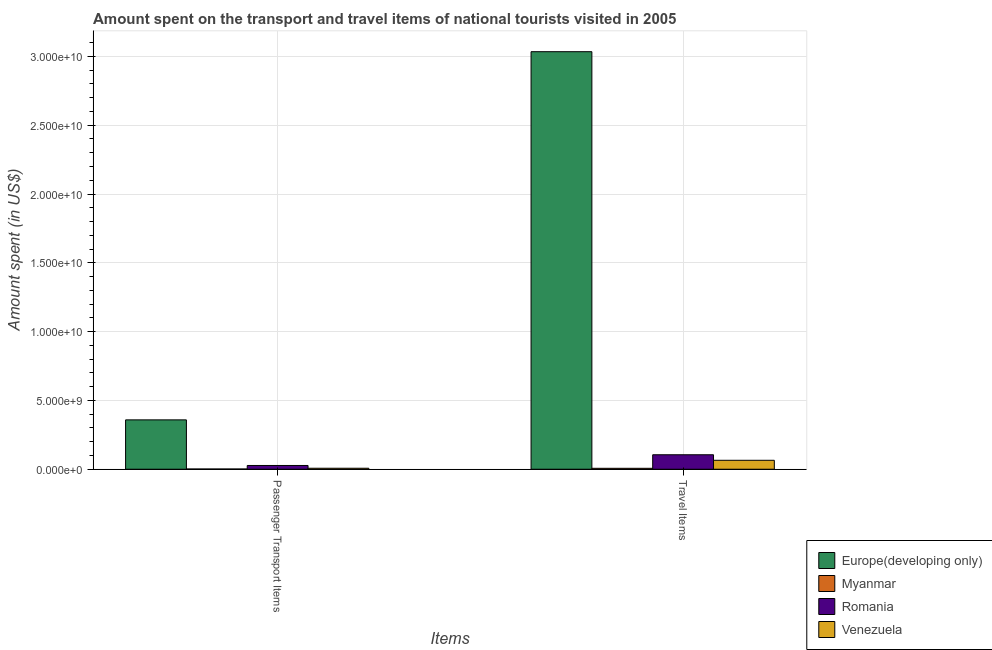How many bars are there on the 1st tick from the left?
Ensure brevity in your answer.  4. How many bars are there on the 1st tick from the right?
Your response must be concise. 4. What is the label of the 2nd group of bars from the left?
Make the answer very short. Travel Items. What is the amount spent in travel items in Romania?
Provide a short and direct response. 1.05e+09. Across all countries, what is the maximum amount spent in travel items?
Provide a short and direct response. 3.03e+1. Across all countries, what is the minimum amount spent on passenger transport items?
Provide a short and direct response. 1.60e+07. In which country was the amount spent in travel items maximum?
Provide a short and direct response. Europe(developing only). In which country was the amount spent in travel items minimum?
Your answer should be very brief. Myanmar. What is the total amount spent in travel items in the graph?
Give a very brief answer. 3.21e+1. What is the difference between the amount spent on passenger transport items in Venezuela and that in Myanmar?
Make the answer very short. 5.60e+07. What is the average amount spent on passenger transport items per country?
Your answer should be very brief. 9.87e+08. What is the difference between the amount spent on passenger transport items and amount spent in travel items in Myanmar?
Your answer should be very brief. -5.10e+07. In how many countries, is the amount spent in travel items greater than 9000000000 US$?
Your answer should be very brief. 1. What is the ratio of the amount spent in travel items in Myanmar to that in Venezuela?
Provide a succinct answer. 0.1. Is the amount spent on passenger transport items in Romania less than that in Venezuela?
Make the answer very short. No. What does the 2nd bar from the left in Passenger Transport Items represents?
Offer a terse response. Myanmar. What does the 1st bar from the right in Passenger Transport Items represents?
Offer a very short reply. Venezuela. How many bars are there?
Your answer should be compact. 8. Are all the bars in the graph horizontal?
Offer a terse response. No. How many countries are there in the graph?
Offer a terse response. 4. Are the values on the major ticks of Y-axis written in scientific E-notation?
Your answer should be compact. Yes. Does the graph contain any zero values?
Give a very brief answer. No. Does the graph contain grids?
Your response must be concise. Yes. How are the legend labels stacked?
Keep it short and to the point. Vertical. What is the title of the graph?
Your response must be concise. Amount spent on the transport and travel items of national tourists visited in 2005. What is the label or title of the X-axis?
Ensure brevity in your answer.  Items. What is the label or title of the Y-axis?
Your answer should be compact. Amount spent (in US$). What is the Amount spent (in US$) in Europe(developing only) in Passenger Transport Items?
Your response must be concise. 3.59e+09. What is the Amount spent (in US$) in Myanmar in Passenger Transport Items?
Give a very brief answer. 1.60e+07. What is the Amount spent (in US$) of Romania in Passenger Transport Items?
Make the answer very short. 2.73e+08. What is the Amount spent (in US$) of Venezuela in Passenger Transport Items?
Offer a terse response. 7.20e+07. What is the Amount spent (in US$) of Europe(developing only) in Travel Items?
Offer a terse response. 3.03e+1. What is the Amount spent (in US$) in Myanmar in Travel Items?
Your answer should be very brief. 6.70e+07. What is the Amount spent (in US$) of Romania in Travel Items?
Give a very brief answer. 1.05e+09. What is the Amount spent (in US$) of Venezuela in Travel Items?
Your answer should be very brief. 6.50e+08. Across all Items, what is the maximum Amount spent (in US$) of Europe(developing only)?
Provide a short and direct response. 3.03e+1. Across all Items, what is the maximum Amount spent (in US$) in Myanmar?
Offer a very short reply. 6.70e+07. Across all Items, what is the maximum Amount spent (in US$) in Romania?
Make the answer very short. 1.05e+09. Across all Items, what is the maximum Amount spent (in US$) of Venezuela?
Provide a succinct answer. 6.50e+08. Across all Items, what is the minimum Amount spent (in US$) in Europe(developing only)?
Your answer should be very brief. 3.59e+09. Across all Items, what is the minimum Amount spent (in US$) in Myanmar?
Provide a short and direct response. 1.60e+07. Across all Items, what is the minimum Amount spent (in US$) of Romania?
Your answer should be compact. 2.73e+08. Across all Items, what is the minimum Amount spent (in US$) in Venezuela?
Your answer should be very brief. 7.20e+07. What is the total Amount spent (in US$) in Europe(developing only) in the graph?
Ensure brevity in your answer.  3.39e+1. What is the total Amount spent (in US$) in Myanmar in the graph?
Provide a succinct answer. 8.30e+07. What is the total Amount spent (in US$) of Romania in the graph?
Keep it short and to the point. 1.32e+09. What is the total Amount spent (in US$) of Venezuela in the graph?
Your answer should be compact. 7.22e+08. What is the difference between the Amount spent (in US$) of Europe(developing only) in Passenger Transport Items and that in Travel Items?
Offer a very short reply. -2.68e+1. What is the difference between the Amount spent (in US$) of Myanmar in Passenger Transport Items and that in Travel Items?
Make the answer very short. -5.10e+07. What is the difference between the Amount spent (in US$) of Romania in Passenger Transport Items and that in Travel Items?
Give a very brief answer. -7.79e+08. What is the difference between the Amount spent (in US$) in Venezuela in Passenger Transport Items and that in Travel Items?
Provide a succinct answer. -5.78e+08. What is the difference between the Amount spent (in US$) of Europe(developing only) in Passenger Transport Items and the Amount spent (in US$) of Myanmar in Travel Items?
Your answer should be very brief. 3.52e+09. What is the difference between the Amount spent (in US$) in Europe(developing only) in Passenger Transport Items and the Amount spent (in US$) in Romania in Travel Items?
Ensure brevity in your answer.  2.54e+09. What is the difference between the Amount spent (in US$) in Europe(developing only) in Passenger Transport Items and the Amount spent (in US$) in Venezuela in Travel Items?
Ensure brevity in your answer.  2.94e+09. What is the difference between the Amount spent (in US$) of Myanmar in Passenger Transport Items and the Amount spent (in US$) of Romania in Travel Items?
Provide a short and direct response. -1.04e+09. What is the difference between the Amount spent (in US$) in Myanmar in Passenger Transport Items and the Amount spent (in US$) in Venezuela in Travel Items?
Your answer should be very brief. -6.34e+08. What is the difference between the Amount spent (in US$) in Romania in Passenger Transport Items and the Amount spent (in US$) in Venezuela in Travel Items?
Keep it short and to the point. -3.77e+08. What is the average Amount spent (in US$) of Europe(developing only) per Items?
Provide a short and direct response. 1.70e+1. What is the average Amount spent (in US$) of Myanmar per Items?
Make the answer very short. 4.15e+07. What is the average Amount spent (in US$) in Romania per Items?
Your answer should be compact. 6.62e+08. What is the average Amount spent (in US$) in Venezuela per Items?
Provide a succinct answer. 3.61e+08. What is the difference between the Amount spent (in US$) of Europe(developing only) and Amount spent (in US$) of Myanmar in Passenger Transport Items?
Your answer should be compact. 3.57e+09. What is the difference between the Amount spent (in US$) in Europe(developing only) and Amount spent (in US$) in Romania in Passenger Transport Items?
Your response must be concise. 3.31e+09. What is the difference between the Amount spent (in US$) in Europe(developing only) and Amount spent (in US$) in Venezuela in Passenger Transport Items?
Offer a very short reply. 3.52e+09. What is the difference between the Amount spent (in US$) in Myanmar and Amount spent (in US$) in Romania in Passenger Transport Items?
Offer a very short reply. -2.57e+08. What is the difference between the Amount spent (in US$) of Myanmar and Amount spent (in US$) of Venezuela in Passenger Transport Items?
Offer a terse response. -5.60e+07. What is the difference between the Amount spent (in US$) of Romania and Amount spent (in US$) of Venezuela in Passenger Transport Items?
Give a very brief answer. 2.01e+08. What is the difference between the Amount spent (in US$) in Europe(developing only) and Amount spent (in US$) in Myanmar in Travel Items?
Your response must be concise. 3.03e+1. What is the difference between the Amount spent (in US$) of Europe(developing only) and Amount spent (in US$) of Romania in Travel Items?
Make the answer very short. 2.93e+1. What is the difference between the Amount spent (in US$) of Europe(developing only) and Amount spent (in US$) of Venezuela in Travel Items?
Your answer should be very brief. 2.97e+1. What is the difference between the Amount spent (in US$) in Myanmar and Amount spent (in US$) in Romania in Travel Items?
Your answer should be compact. -9.85e+08. What is the difference between the Amount spent (in US$) in Myanmar and Amount spent (in US$) in Venezuela in Travel Items?
Make the answer very short. -5.83e+08. What is the difference between the Amount spent (in US$) of Romania and Amount spent (in US$) of Venezuela in Travel Items?
Give a very brief answer. 4.02e+08. What is the ratio of the Amount spent (in US$) in Europe(developing only) in Passenger Transport Items to that in Travel Items?
Offer a terse response. 0.12. What is the ratio of the Amount spent (in US$) of Myanmar in Passenger Transport Items to that in Travel Items?
Your answer should be very brief. 0.24. What is the ratio of the Amount spent (in US$) in Romania in Passenger Transport Items to that in Travel Items?
Your answer should be very brief. 0.26. What is the ratio of the Amount spent (in US$) of Venezuela in Passenger Transport Items to that in Travel Items?
Offer a terse response. 0.11. What is the difference between the highest and the second highest Amount spent (in US$) of Europe(developing only)?
Your response must be concise. 2.68e+1. What is the difference between the highest and the second highest Amount spent (in US$) of Myanmar?
Offer a very short reply. 5.10e+07. What is the difference between the highest and the second highest Amount spent (in US$) of Romania?
Provide a short and direct response. 7.79e+08. What is the difference between the highest and the second highest Amount spent (in US$) of Venezuela?
Your answer should be compact. 5.78e+08. What is the difference between the highest and the lowest Amount spent (in US$) of Europe(developing only)?
Your response must be concise. 2.68e+1. What is the difference between the highest and the lowest Amount spent (in US$) in Myanmar?
Your response must be concise. 5.10e+07. What is the difference between the highest and the lowest Amount spent (in US$) in Romania?
Your answer should be very brief. 7.79e+08. What is the difference between the highest and the lowest Amount spent (in US$) of Venezuela?
Your response must be concise. 5.78e+08. 